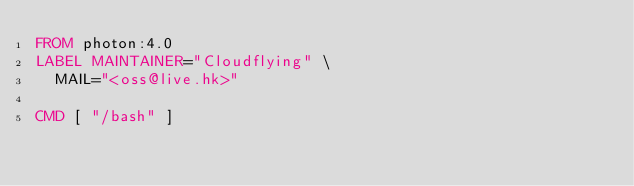<code> <loc_0><loc_0><loc_500><loc_500><_Dockerfile_>FROM photon:4.0
LABEL MAINTAINER="Cloudflying" \
  MAIL="<oss@live.hk>"

CMD [ "/bash" ]
</code> 